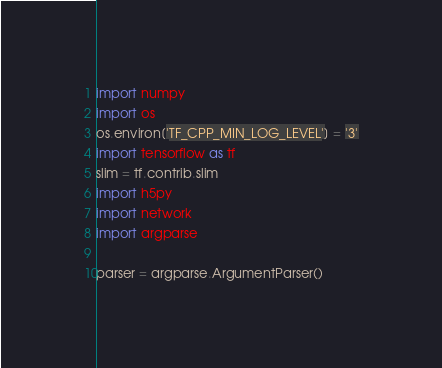<code> <loc_0><loc_0><loc_500><loc_500><_Python_>import numpy
import os
os.environ['TF_CPP_MIN_LOG_LEVEL'] = '3'
import tensorflow as tf
slim = tf.contrib.slim
import h5py
import network
import argparse

parser = argparse.ArgumentParser()</code> 